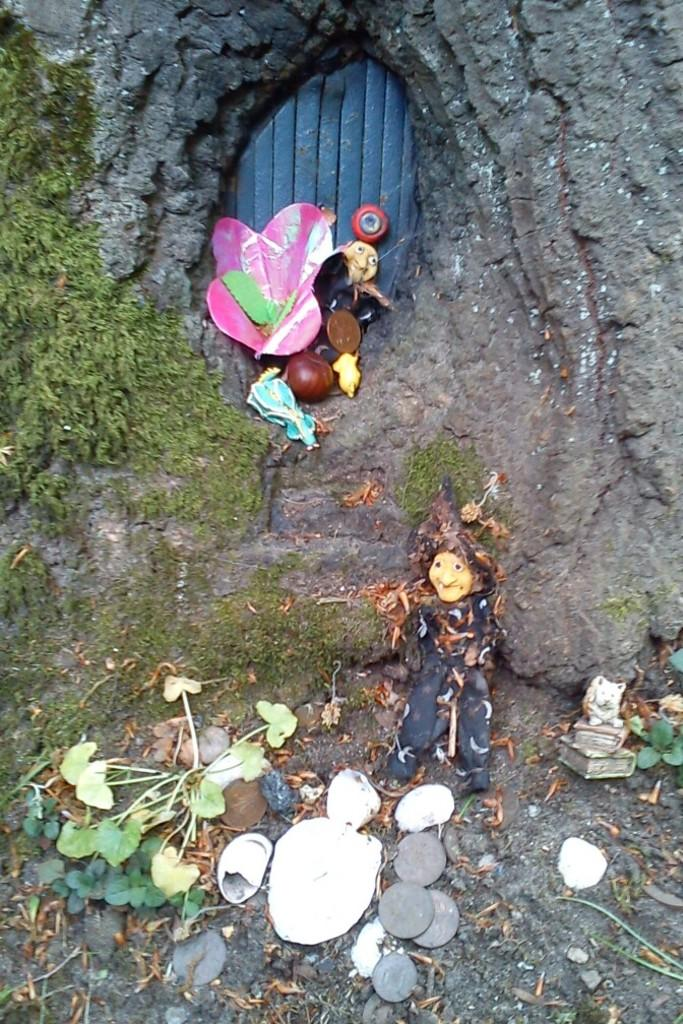What types of items can be seen in the image? There are toys, plants, papers, and other objects in the image. Can you describe the plants in the image? The plants are not specifically described, but they are present in the image. What other objects can be seen in the image besides the toys, plants, and papers? There are other objects in the image, but their specific nature is not mentioned in the provided facts. What unique feature is present in the background of the image? There is a door in a tree trunk in the background of the image. What type of locket is hanging from the tree branch in the image? There is no locket hanging from a tree branch in the image. How does the nerve system of the plants in the image function? The provided facts do not mention anything about the plants' nerve systems, so it is not possible to answer this question. 